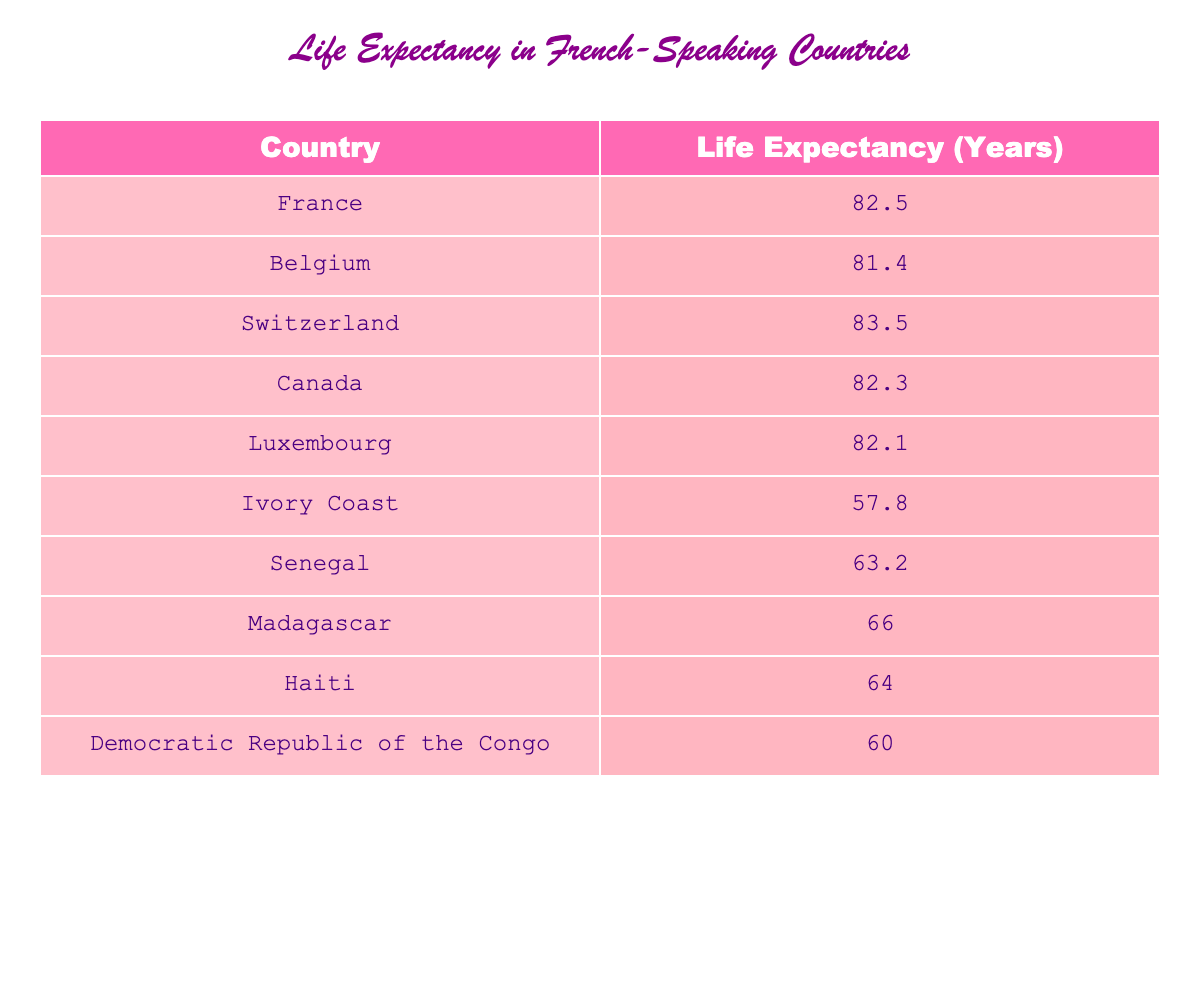What is the life expectancy in Switzerland? The table shows that Switzerland has a life expectancy of 83.5 years.
Answer: 83.5 Which country has the lowest life expectancy? According to the table, Ivory Coast has the lowest life expectancy at 57.8 years.
Answer: Ivory Coast What is the difference in life expectancy between Canada and Haiti? Canada has a life expectancy of 82.3 years, and Haiti has 64.0 years. The difference is 82.3 - 64.0 = 18.3 years.
Answer: 18.3 Is the life expectancy in France higher than that in Senegal? The table indicates that the life expectancy in France is 82.5 years, while it is 63.2 years in Senegal. Therefore, France's life expectancy is higher than Senegal's.
Answer: Yes What is the average life expectancy of all the countries listed in the table? To calculate the average, add all the life expectancy values (82.5 + 81.4 + 83.5 + 82.3 + 82.1 + 57.8 + 63.2 + 66.0 + 64.0 + 60.0) = 82.0 and then divide by the number of countries (10). Thus, the average is 820.0 / 10 = 82.0.
Answer: 82.0 Which has a higher life expectancy: Belgium or the Democratic Republic of the Congo? Belgium's life expectancy is 81.4 years, while the Democratic Republic of the Congo has 60.0 years. Therefore, Belgium has a higher life expectancy than the Democratic Republic of the Congo.
Answer: Belgium How many countries have a life expectancy of over 80 years? From the table, France (82.5), Belgium (81.4), Switzerland (83.5), and Canada (82.3) all have life expectancies over 80 years. There are 4 such countries.
Answer: 4 What is the total life expectancy of all African countries listed? The African countries listed are Ivory Coast (57.8), Senegal (63.2), Madagascar (66.0), Haiti (64.0), and the Democratic Republic of the Congo (60.0). Adding these (57.8 + 63.2 + 66.0 + 64.0 + 60.0) gives a total of 311.0 years.
Answer: 311.0 Which country has a life expectancy just below the average life expectancy of the dataset? The average life expectancy is 82.0 years. Looking at each country, that would be Belgium (81.4 years) which is just below the average.
Answer: Belgium 